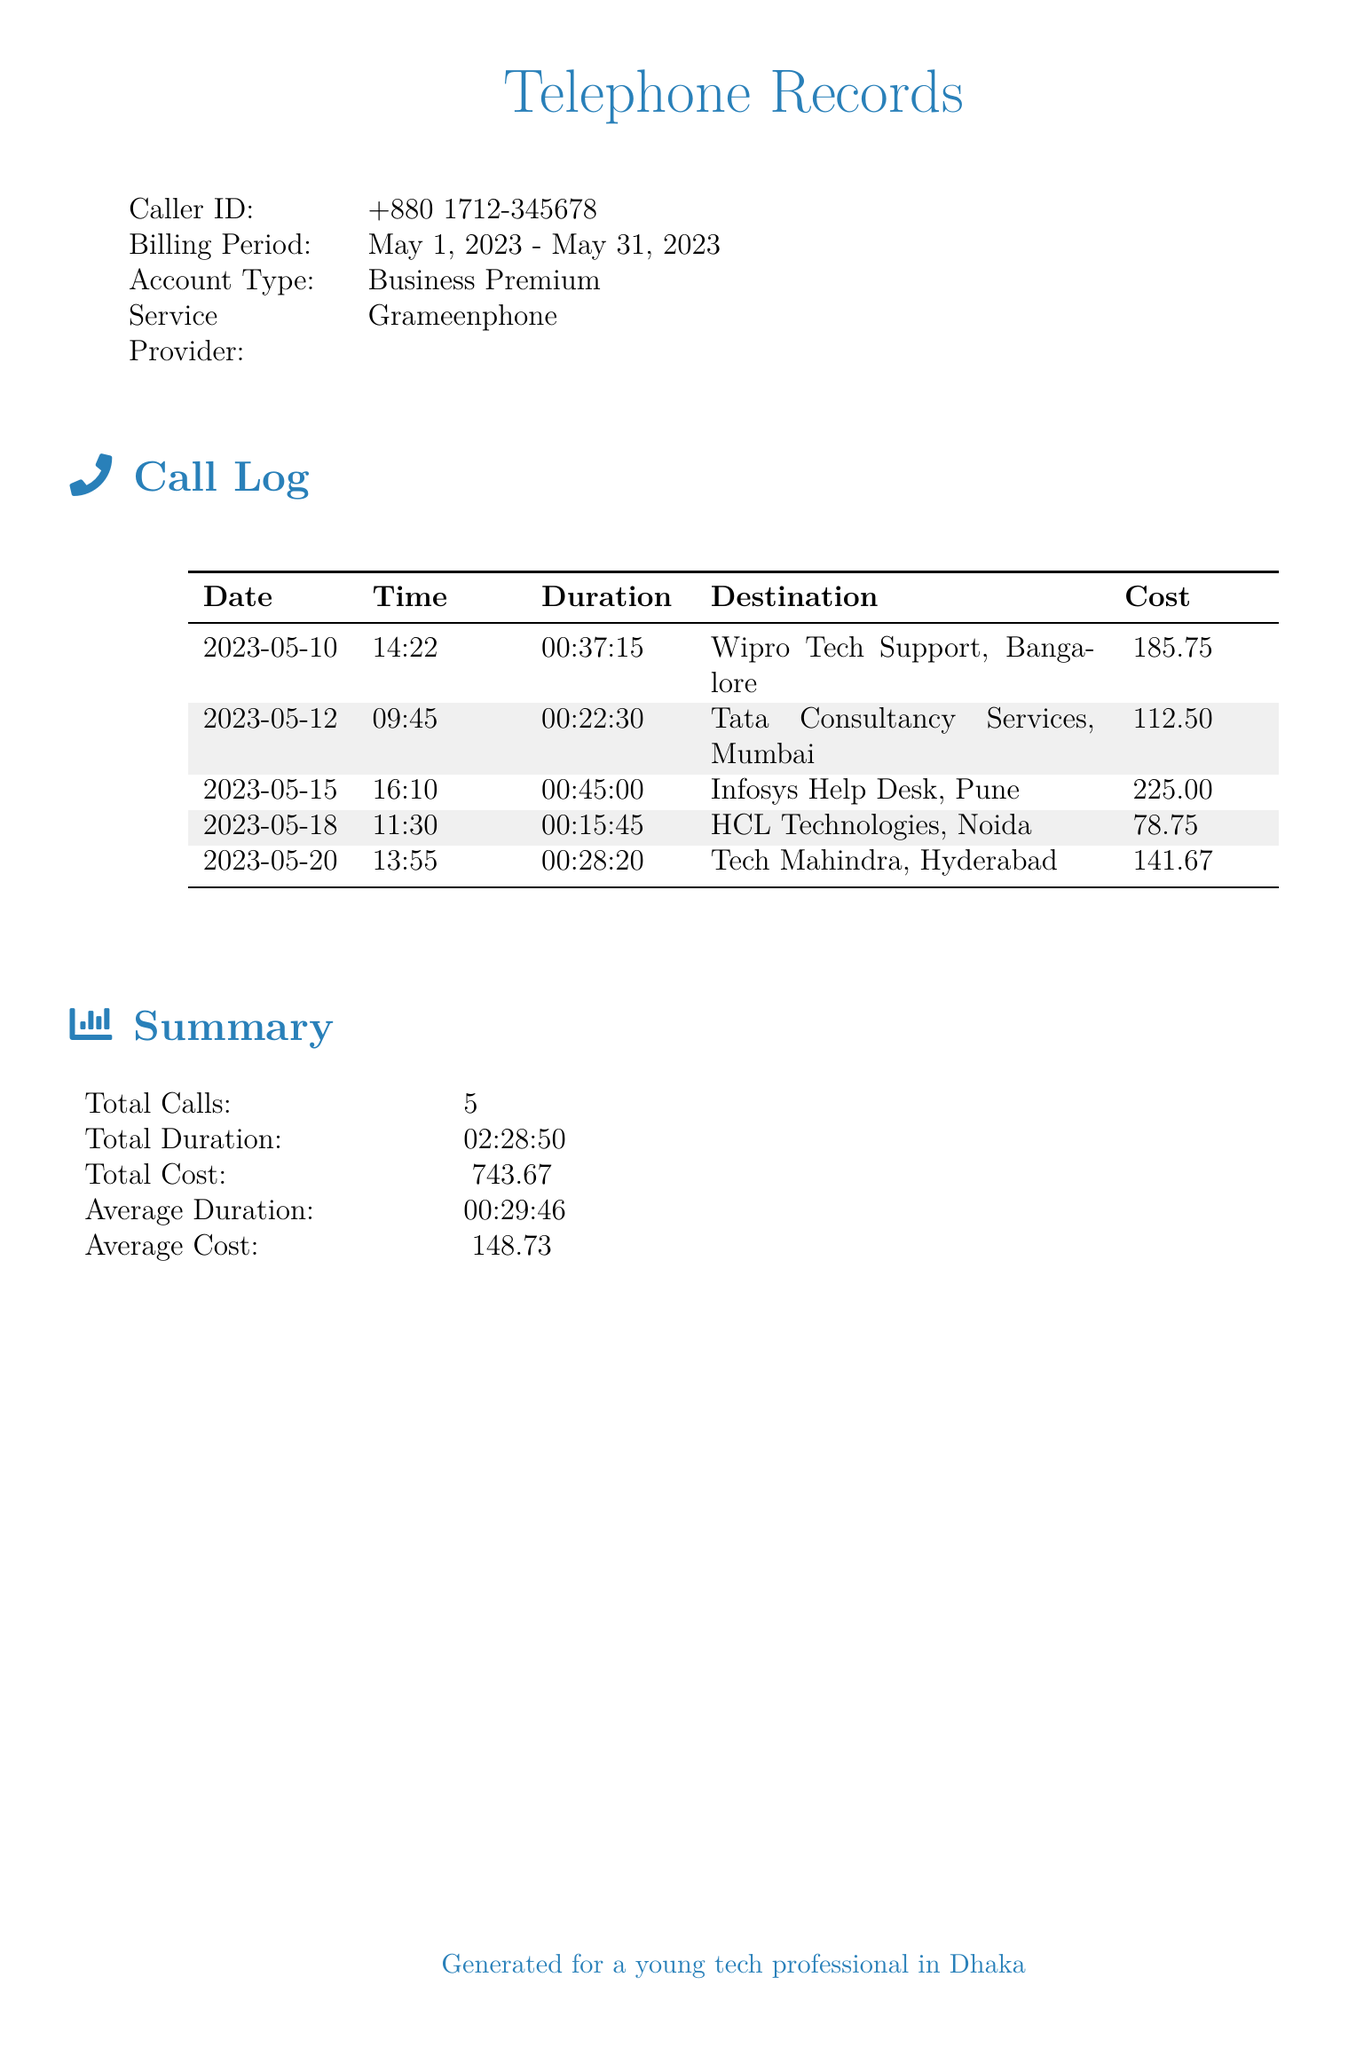What is the caller ID? The caller ID is specific to the account holder and is provided in the document.
Answer: +880 1712-345678 What is the billing period? The billing period specifies the time frame for the recorded calls.
Answer: May 1, 2023 - May 31, 2023 How many total calls were made? The total number of calls summarizes the count of individual entries in the call log.
Answer: 5 What is the total cost of the calls? The total cost aggregates the individual call costs listed in the summary section.
Answer: ৳743.67 Which company was called on May 15, 2023? The document lists specific companies corresponding to the call dates in the log.
Answer: Infosys Help Desk, Pune What is the average duration of calls? Average duration is calculated from the total duration of all calls divided by the number of calls.
Answer: 00:29:46 Which company had the highest call cost? The highest call cost can be determined by comparing the individual costs listed.
Answer: Infosys Help Desk, Pune What was the duration of the call to HCL Technologies? The duration is specified for each call in the log, indicating how long the calls lasted.
Answer: 00:15:45 What time was the call to Tata Consultancy Services made? The specific time of each call is documented in the call log.
Answer: 09:45 